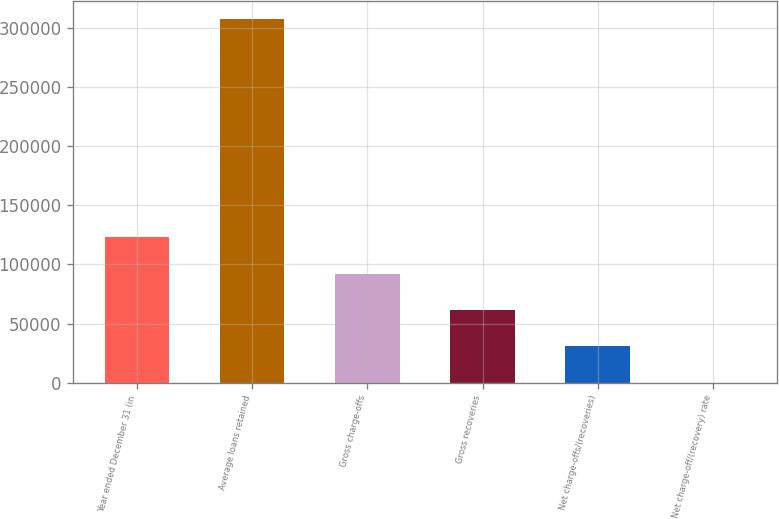Convert chart to OTSL. <chart><loc_0><loc_0><loc_500><loc_500><bar_chart><fcel>Year ended December 31 (in<fcel>Average loans retained<fcel>Gross charge-offs<fcel>Gross recoveries<fcel>Net charge-offs/(recoveries)<fcel>Net charge-off/(recovery) rate<nl><fcel>122936<fcel>307340<fcel>92202<fcel>61468<fcel>30734<fcel>0.01<nl></chart> 